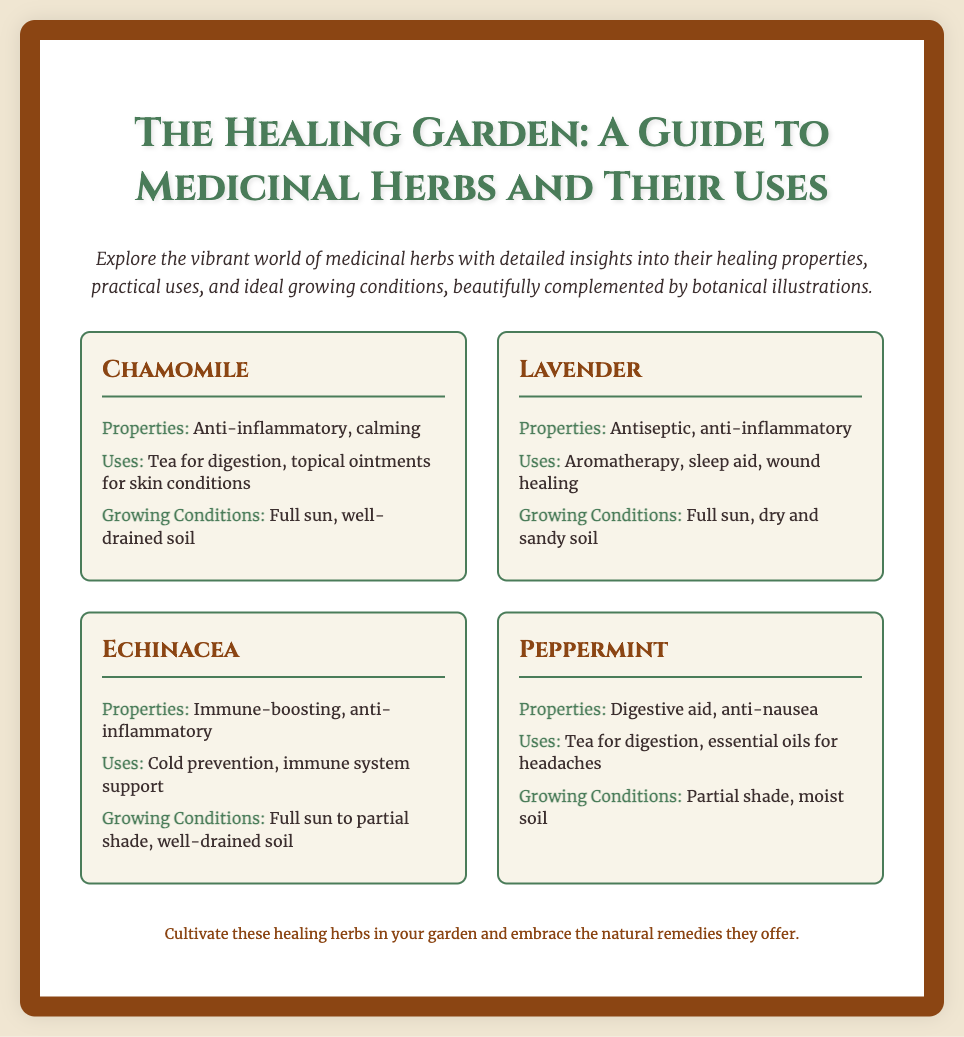What is the title of the poster? The title of the poster is displayed prominently at the top of the document.
Answer: The Healing Garden: A Guide to Medicinal Herbs and Their Uses What are the properties of Chamomile? The properties of Chamomile are listed in its section on the poster.
Answer: Anti-inflammatory, calming What is one use of Lavender? The uses of Lavender are provided in its section, which can be directly cited.
Answer: Aromatherapy What type of soil is ideal for Echinacea? The information about ideal growing conditions is included under each herb.
Answer: Well-drained soil What is the main theme of the document? The theme is evident in the title and introductory text of the poster.
Answer: Medicinal herbs and their uses Which herb has properties that aid digestion? The properties of each herb include specific benefits that are mentioned.
Answer: Peppermint How many herbs are featured in the poster? The number of herbs is determined from the list displayed in the document.
Answer: Four What color is used for the header text? The color descriptions are part of the aesthetic elements noted in the document's style.
Answer: Green What type of document is this? The format and content of the document indicate its purpose.
Answer: Poster 